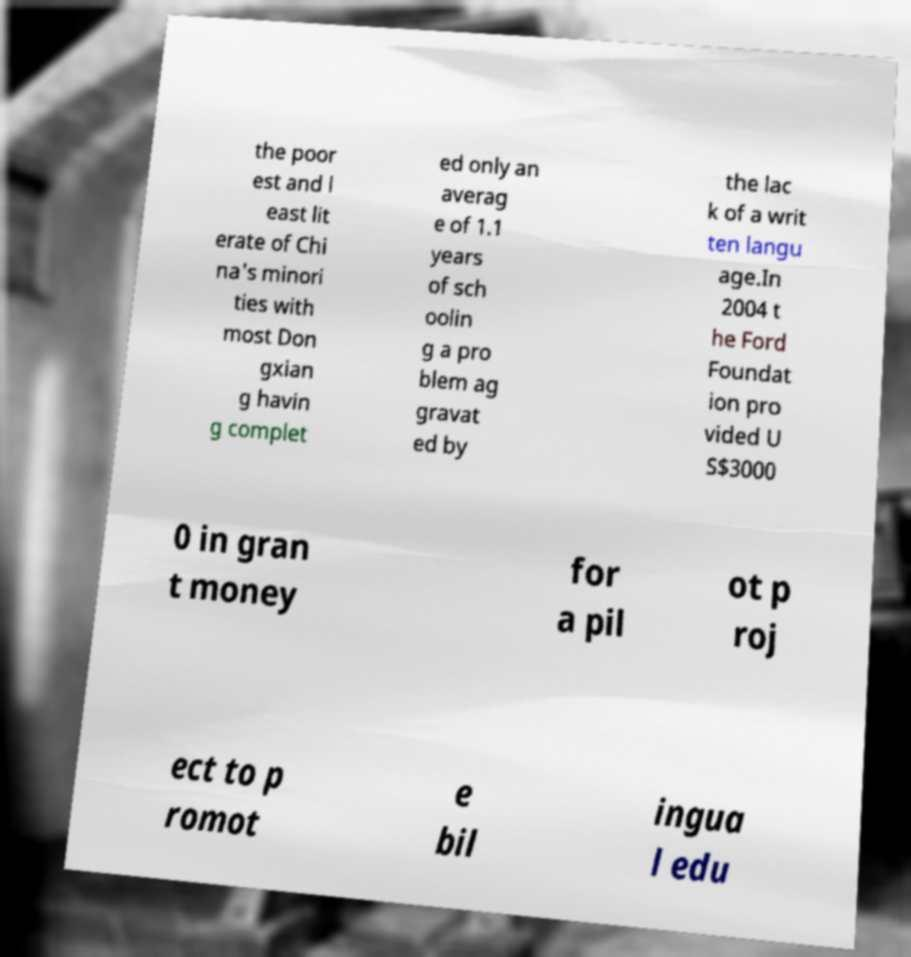Can you accurately transcribe the text from the provided image for me? the poor est and l east lit erate of Chi na's minori ties with most Don gxian g havin g complet ed only an averag e of 1.1 years of sch oolin g a pro blem ag gravat ed by the lac k of a writ ten langu age.In 2004 t he Ford Foundat ion pro vided U S$3000 0 in gran t money for a pil ot p roj ect to p romot e bil ingua l edu 